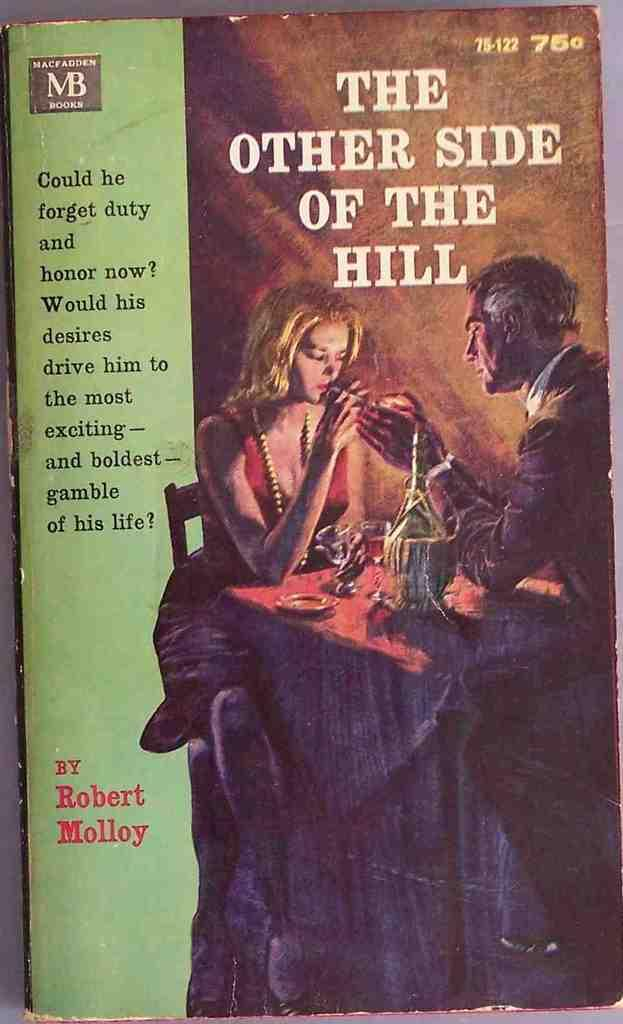<image>
Provide a brief description of the given image. The cover of a beat up book titled The Other Side of The Hill 